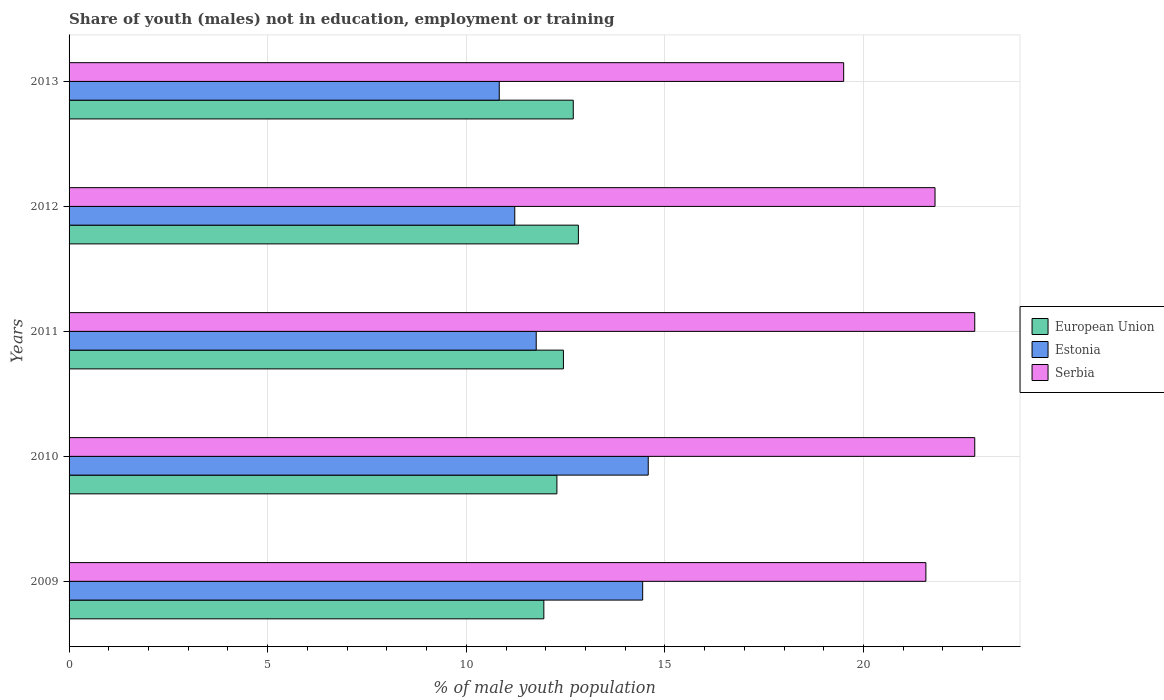How many different coloured bars are there?
Your answer should be very brief. 3. How many groups of bars are there?
Keep it short and to the point. 5. How many bars are there on the 3rd tick from the top?
Your answer should be compact. 3. In how many cases, is the number of bars for a given year not equal to the number of legend labels?
Your response must be concise. 0. What is the percentage of unemployed males population in in European Union in 2009?
Keep it short and to the point. 11.95. Across all years, what is the maximum percentage of unemployed males population in in Estonia?
Ensure brevity in your answer.  14.58. Across all years, what is the minimum percentage of unemployed males population in in Estonia?
Your response must be concise. 10.83. What is the total percentage of unemployed males population in in Estonia in the graph?
Make the answer very short. 62.83. What is the difference between the percentage of unemployed males population in in European Union in 2010 and that in 2013?
Offer a very short reply. -0.41. What is the difference between the percentage of unemployed males population in in Estonia in 2010 and the percentage of unemployed males population in in Serbia in 2012?
Offer a very short reply. -7.22. What is the average percentage of unemployed males population in in Serbia per year?
Provide a short and direct response. 21.69. In the year 2012, what is the difference between the percentage of unemployed males population in in Estonia and percentage of unemployed males population in in European Union?
Provide a succinct answer. -1.6. What is the ratio of the percentage of unemployed males population in in Estonia in 2009 to that in 2010?
Make the answer very short. 0.99. Is the percentage of unemployed males population in in Estonia in 2010 less than that in 2013?
Your response must be concise. No. Is the difference between the percentage of unemployed males population in in Estonia in 2011 and 2012 greater than the difference between the percentage of unemployed males population in in European Union in 2011 and 2012?
Provide a succinct answer. Yes. What is the difference between the highest and the second highest percentage of unemployed males population in in European Union?
Keep it short and to the point. 0.13. What is the difference between the highest and the lowest percentage of unemployed males population in in European Union?
Your answer should be compact. 0.87. Is the sum of the percentage of unemployed males population in in Estonia in 2011 and 2012 greater than the maximum percentage of unemployed males population in in European Union across all years?
Provide a short and direct response. Yes. What does the 1st bar from the top in 2011 represents?
Offer a very short reply. Serbia. What does the 3rd bar from the bottom in 2009 represents?
Make the answer very short. Serbia. Are all the bars in the graph horizontal?
Ensure brevity in your answer.  Yes. What is the difference between two consecutive major ticks on the X-axis?
Give a very brief answer. 5. Are the values on the major ticks of X-axis written in scientific E-notation?
Keep it short and to the point. No. Does the graph contain any zero values?
Keep it short and to the point. No. Does the graph contain grids?
Your response must be concise. Yes. How many legend labels are there?
Make the answer very short. 3. How are the legend labels stacked?
Give a very brief answer. Vertical. What is the title of the graph?
Offer a terse response. Share of youth (males) not in education, employment or training. What is the label or title of the X-axis?
Provide a short and direct response. % of male youth population. What is the % of male youth population of European Union in 2009?
Offer a terse response. 11.95. What is the % of male youth population of Estonia in 2009?
Your answer should be compact. 14.44. What is the % of male youth population in Serbia in 2009?
Make the answer very short. 21.57. What is the % of male youth population of European Union in 2010?
Offer a terse response. 12.28. What is the % of male youth population of Estonia in 2010?
Provide a succinct answer. 14.58. What is the % of male youth population in Serbia in 2010?
Ensure brevity in your answer.  22.8. What is the % of male youth population in European Union in 2011?
Offer a very short reply. 12.45. What is the % of male youth population of Estonia in 2011?
Make the answer very short. 11.76. What is the % of male youth population in Serbia in 2011?
Offer a terse response. 22.8. What is the % of male youth population in European Union in 2012?
Offer a very short reply. 12.82. What is the % of male youth population in Estonia in 2012?
Make the answer very short. 11.22. What is the % of male youth population of Serbia in 2012?
Give a very brief answer. 21.8. What is the % of male youth population in European Union in 2013?
Offer a very short reply. 12.69. What is the % of male youth population of Estonia in 2013?
Keep it short and to the point. 10.83. Across all years, what is the maximum % of male youth population of European Union?
Offer a terse response. 12.82. Across all years, what is the maximum % of male youth population of Estonia?
Your answer should be compact. 14.58. Across all years, what is the maximum % of male youth population of Serbia?
Your answer should be compact. 22.8. Across all years, what is the minimum % of male youth population of European Union?
Ensure brevity in your answer.  11.95. Across all years, what is the minimum % of male youth population in Estonia?
Your answer should be compact. 10.83. Across all years, what is the minimum % of male youth population in Serbia?
Provide a short and direct response. 19.5. What is the total % of male youth population of European Union in the graph?
Provide a succinct answer. 62.19. What is the total % of male youth population of Estonia in the graph?
Your answer should be compact. 62.83. What is the total % of male youth population of Serbia in the graph?
Your answer should be very brief. 108.47. What is the difference between the % of male youth population of European Union in 2009 and that in 2010?
Give a very brief answer. -0.33. What is the difference between the % of male youth population in Estonia in 2009 and that in 2010?
Offer a very short reply. -0.14. What is the difference between the % of male youth population of Serbia in 2009 and that in 2010?
Provide a short and direct response. -1.23. What is the difference between the % of male youth population in European Union in 2009 and that in 2011?
Give a very brief answer. -0.49. What is the difference between the % of male youth population of Estonia in 2009 and that in 2011?
Your answer should be very brief. 2.68. What is the difference between the % of male youth population in Serbia in 2009 and that in 2011?
Your answer should be very brief. -1.23. What is the difference between the % of male youth population in European Union in 2009 and that in 2012?
Your response must be concise. -0.87. What is the difference between the % of male youth population of Estonia in 2009 and that in 2012?
Offer a terse response. 3.22. What is the difference between the % of male youth population of Serbia in 2009 and that in 2012?
Provide a succinct answer. -0.23. What is the difference between the % of male youth population in European Union in 2009 and that in 2013?
Offer a very short reply. -0.74. What is the difference between the % of male youth population in Estonia in 2009 and that in 2013?
Make the answer very short. 3.61. What is the difference between the % of male youth population of Serbia in 2009 and that in 2013?
Ensure brevity in your answer.  2.07. What is the difference between the % of male youth population of European Union in 2010 and that in 2011?
Keep it short and to the point. -0.16. What is the difference between the % of male youth population of Estonia in 2010 and that in 2011?
Ensure brevity in your answer.  2.82. What is the difference between the % of male youth population of Serbia in 2010 and that in 2011?
Provide a short and direct response. 0. What is the difference between the % of male youth population in European Union in 2010 and that in 2012?
Make the answer very short. -0.54. What is the difference between the % of male youth population of Estonia in 2010 and that in 2012?
Give a very brief answer. 3.36. What is the difference between the % of male youth population in Serbia in 2010 and that in 2012?
Keep it short and to the point. 1. What is the difference between the % of male youth population of European Union in 2010 and that in 2013?
Your answer should be compact. -0.41. What is the difference between the % of male youth population of Estonia in 2010 and that in 2013?
Ensure brevity in your answer.  3.75. What is the difference between the % of male youth population of Serbia in 2010 and that in 2013?
Your answer should be very brief. 3.3. What is the difference between the % of male youth population of European Union in 2011 and that in 2012?
Provide a short and direct response. -0.38. What is the difference between the % of male youth population of Estonia in 2011 and that in 2012?
Give a very brief answer. 0.54. What is the difference between the % of male youth population of European Union in 2011 and that in 2013?
Your answer should be compact. -0.25. What is the difference between the % of male youth population of Estonia in 2011 and that in 2013?
Your answer should be very brief. 0.93. What is the difference between the % of male youth population of Serbia in 2011 and that in 2013?
Give a very brief answer. 3.3. What is the difference between the % of male youth population in European Union in 2012 and that in 2013?
Keep it short and to the point. 0.13. What is the difference between the % of male youth population in Estonia in 2012 and that in 2013?
Your answer should be compact. 0.39. What is the difference between the % of male youth population in European Union in 2009 and the % of male youth population in Estonia in 2010?
Ensure brevity in your answer.  -2.63. What is the difference between the % of male youth population of European Union in 2009 and the % of male youth population of Serbia in 2010?
Your answer should be very brief. -10.85. What is the difference between the % of male youth population in Estonia in 2009 and the % of male youth population in Serbia in 2010?
Your answer should be compact. -8.36. What is the difference between the % of male youth population of European Union in 2009 and the % of male youth population of Estonia in 2011?
Give a very brief answer. 0.19. What is the difference between the % of male youth population of European Union in 2009 and the % of male youth population of Serbia in 2011?
Ensure brevity in your answer.  -10.85. What is the difference between the % of male youth population of Estonia in 2009 and the % of male youth population of Serbia in 2011?
Make the answer very short. -8.36. What is the difference between the % of male youth population in European Union in 2009 and the % of male youth population in Estonia in 2012?
Keep it short and to the point. 0.73. What is the difference between the % of male youth population in European Union in 2009 and the % of male youth population in Serbia in 2012?
Offer a terse response. -9.85. What is the difference between the % of male youth population of Estonia in 2009 and the % of male youth population of Serbia in 2012?
Give a very brief answer. -7.36. What is the difference between the % of male youth population of European Union in 2009 and the % of male youth population of Estonia in 2013?
Keep it short and to the point. 1.12. What is the difference between the % of male youth population in European Union in 2009 and the % of male youth population in Serbia in 2013?
Your answer should be compact. -7.55. What is the difference between the % of male youth population in Estonia in 2009 and the % of male youth population in Serbia in 2013?
Keep it short and to the point. -5.06. What is the difference between the % of male youth population in European Union in 2010 and the % of male youth population in Estonia in 2011?
Offer a very short reply. 0.52. What is the difference between the % of male youth population in European Union in 2010 and the % of male youth population in Serbia in 2011?
Keep it short and to the point. -10.52. What is the difference between the % of male youth population of Estonia in 2010 and the % of male youth population of Serbia in 2011?
Ensure brevity in your answer.  -8.22. What is the difference between the % of male youth population of European Union in 2010 and the % of male youth population of Estonia in 2012?
Offer a terse response. 1.06. What is the difference between the % of male youth population of European Union in 2010 and the % of male youth population of Serbia in 2012?
Your answer should be compact. -9.52. What is the difference between the % of male youth population in Estonia in 2010 and the % of male youth population in Serbia in 2012?
Give a very brief answer. -7.22. What is the difference between the % of male youth population in European Union in 2010 and the % of male youth population in Estonia in 2013?
Provide a succinct answer. 1.45. What is the difference between the % of male youth population of European Union in 2010 and the % of male youth population of Serbia in 2013?
Provide a succinct answer. -7.22. What is the difference between the % of male youth population of Estonia in 2010 and the % of male youth population of Serbia in 2013?
Your answer should be compact. -4.92. What is the difference between the % of male youth population of European Union in 2011 and the % of male youth population of Estonia in 2012?
Your answer should be compact. 1.23. What is the difference between the % of male youth population in European Union in 2011 and the % of male youth population in Serbia in 2012?
Your answer should be compact. -9.36. What is the difference between the % of male youth population in Estonia in 2011 and the % of male youth population in Serbia in 2012?
Give a very brief answer. -10.04. What is the difference between the % of male youth population of European Union in 2011 and the % of male youth population of Estonia in 2013?
Keep it short and to the point. 1.61. What is the difference between the % of male youth population of European Union in 2011 and the % of male youth population of Serbia in 2013?
Make the answer very short. -7.05. What is the difference between the % of male youth population of Estonia in 2011 and the % of male youth population of Serbia in 2013?
Your response must be concise. -7.74. What is the difference between the % of male youth population in European Union in 2012 and the % of male youth population in Estonia in 2013?
Keep it short and to the point. 1.99. What is the difference between the % of male youth population of European Union in 2012 and the % of male youth population of Serbia in 2013?
Provide a succinct answer. -6.68. What is the difference between the % of male youth population of Estonia in 2012 and the % of male youth population of Serbia in 2013?
Ensure brevity in your answer.  -8.28. What is the average % of male youth population of European Union per year?
Keep it short and to the point. 12.44. What is the average % of male youth population of Estonia per year?
Give a very brief answer. 12.57. What is the average % of male youth population of Serbia per year?
Give a very brief answer. 21.69. In the year 2009, what is the difference between the % of male youth population in European Union and % of male youth population in Estonia?
Your answer should be very brief. -2.49. In the year 2009, what is the difference between the % of male youth population in European Union and % of male youth population in Serbia?
Provide a short and direct response. -9.62. In the year 2009, what is the difference between the % of male youth population in Estonia and % of male youth population in Serbia?
Keep it short and to the point. -7.13. In the year 2010, what is the difference between the % of male youth population in European Union and % of male youth population in Estonia?
Provide a short and direct response. -2.3. In the year 2010, what is the difference between the % of male youth population of European Union and % of male youth population of Serbia?
Your response must be concise. -10.52. In the year 2010, what is the difference between the % of male youth population of Estonia and % of male youth population of Serbia?
Offer a terse response. -8.22. In the year 2011, what is the difference between the % of male youth population of European Union and % of male youth population of Estonia?
Your answer should be very brief. 0.69. In the year 2011, what is the difference between the % of male youth population in European Union and % of male youth population in Serbia?
Ensure brevity in your answer.  -10.36. In the year 2011, what is the difference between the % of male youth population of Estonia and % of male youth population of Serbia?
Offer a very short reply. -11.04. In the year 2012, what is the difference between the % of male youth population in European Union and % of male youth population in Estonia?
Offer a terse response. 1.6. In the year 2012, what is the difference between the % of male youth population of European Union and % of male youth population of Serbia?
Offer a terse response. -8.98. In the year 2012, what is the difference between the % of male youth population of Estonia and % of male youth population of Serbia?
Your answer should be compact. -10.58. In the year 2013, what is the difference between the % of male youth population of European Union and % of male youth population of Estonia?
Your response must be concise. 1.86. In the year 2013, what is the difference between the % of male youth population in European Union and % of male youth population in Serbia?
Make the answer very short. -6.81. In the year 2013, what is the difference between the % of male youth population in Estonia and % of male youth population in Serbia?
Offer a very short reply. -8.67. What is the ratio of the % of male youth population in European Union in 2009 to that in 2010?
Keep it short and to the point. 0.97. What is the ratio of the % of male youth population in Estonia in 2009 to that in 2010?
Make the answer very short. 0.99. What is the ratio of the % of male youth population in Serbia in 2009 to that in 2010?
Your answer should be very brief. 0.95. What is the ratio of the % of male youth population in European Union in 2009 to that in 2011?
Keep it short and to the point. 0.96. What is the ratio of the % of male youth population in Estonia in 2009 to that in 2011?
Keep it short and to the point. 1.23. What is the ratio of the % of male youth population of Serbia in 2009 to that in 2011?
Give a very brief answer. 0.95. What is the ratio of the % of male youth population of European Union in 2009 to that in 2012?
Keep it short and to the point. 0.93. What is the ratio of the % of male youth population of Estonia in 2009 to that in 2012?
Offer a terse response. 1.29. What is the ratio of the % of male youth population in European Union in 2009 to that in 2013?
Provide a short and direct response. 0.94. What is the ratio of the % of male youth population of Serbia in 2009 to that in 2013?
Make the answer very short. 1.11. What is the ratio of the % of male youth population in European Union in 2010 to that in 2011?
Provide a short and direct response. 0.99. What is the ratio of the % of male youth population in Estonia in 2010 to that in 2011?
Keep it short and to the point. 1.24. What is the ratio of the % of male youth population in European Union in 2010 to that in 2012?
Keep it short and to the point. 0.96. What is the ratio of the % of male youth population in Estonia in 2010 to that in 2012?
Your response must be concise. 1.3. What is the ratio of the % of male youth population in Serbia in 2010 to that in 2012?
Provide a succinct answer. 1.05. What is the ratio of the % of male youth population in European Union in 2010 to that in 2013?
Ensure brevity in your answer.  0.97. What is the ratio of the % of male youth population in Estonia in 2010 to that in 2013?
Provide a short and direct response. 1.35. What is the ratio of the % of male youth population of Serbia in 2010 to that in 2013?
Provide a short and direct response. 1.17. What is the ratio of the % of male youth population in European Union in 2011 to that in 2012?
Offer a very short reply. 0.97. What is the ratio of the % of male youth population of Estonia in 2011 to that in 2012?
Offer a very short reply. 1.05. What is the ratio of the % of male youth population in Serbia in 2011 to that in 2012?
Your answer should be very brief. 1.05. What is the ratio of the % of male youth population in European Union in 2011 to that in 2013?
Provide a short and direct response. 0.98. What is the ratio of the % of male youth population in Estonia in 2011 to that in 2013?
Your response must be concise. 1.09. What is the ratio of the % of male youth population of Serbia in 2011 to that in 2013?
Your answer should be compact. 1.17. What is the ratio of the % of male youth population of Estonia in 2012 to that in 2013?
Your answer should be very brief. 1.04. What is the ratio of the % of male youth population of Serbia in 2012 to that in 2013?
Ensure brevity in your answer.  1.12. What is the difference between the highest and the second highest % of male youth population in European Union?
Make the answer very short. 0.13. What is the difference between the highest and the second highest % of male youth population of Estonia?
Your response must be concise. 0.14. What is the difference between the highest and the second highest % of male youth population of Serbia?
Your answer should be very brief. 0. What is the difference between the highest and the lowest % of male youth population in European Union?
Offer a very short reply. 0.87. What is the difference between the highest and the lowest % of male youth population in Estonia?
Keep it short and to the point. 3.75. 